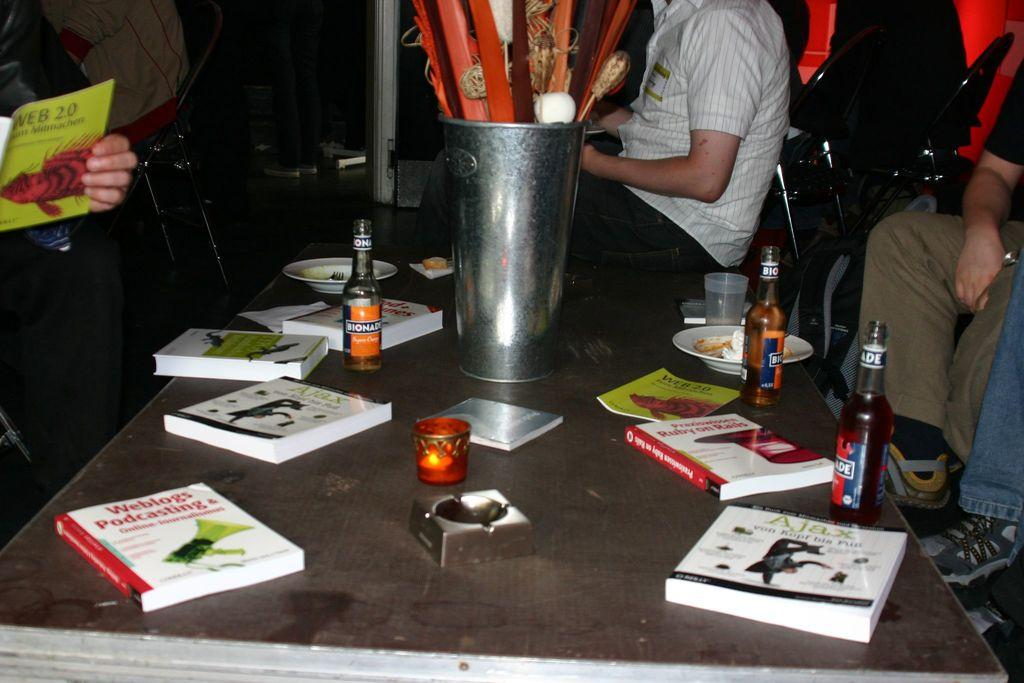What is the main piece of furniture in the image? There is a table in the image. What items can be seen on the table? There are books and bottles on the table. Are there any people present in the image? Yes, there are people around the table. What is the weight of the stick in the image? There is no stick present in the image, so it is not possible to determine its weight. 